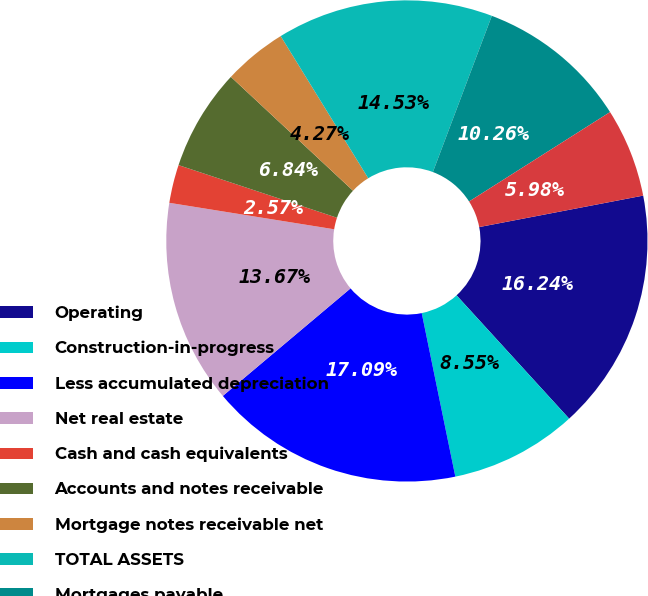Convert chart to OTSL. <chart><loc_0><loc_0><loc_500><loc_500><pie_chart><fcel>Operating<fcel>Construction-in-progress<fcel>Less accumulated depreciation<fcel>Net real estate<fcel>Cash and cash equivalents<fcel>Accounts and notes receivable<fcel>Mortgage notes receivable net<fcel>TOTAL ASSETS<fcel>Mortgages payable<fcel>Capital lease obligations<nl><fcel>16.24%<fcel>8.55%<fcel>17.09%<fcel>13.67%<fcel>2.57%<fcel>6.84%<fcel>4.27%<fcel>14.53%<fcel>10.26%<fcel>5.98%<nl></chart> 